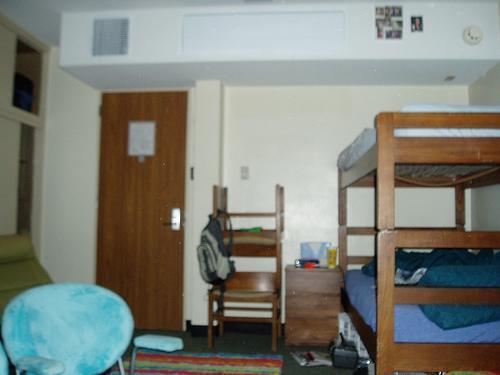How many beds are there?
Give a very brief answer. 2. How many mattresses have blue sheets?
Give a very brief answer. 1. 